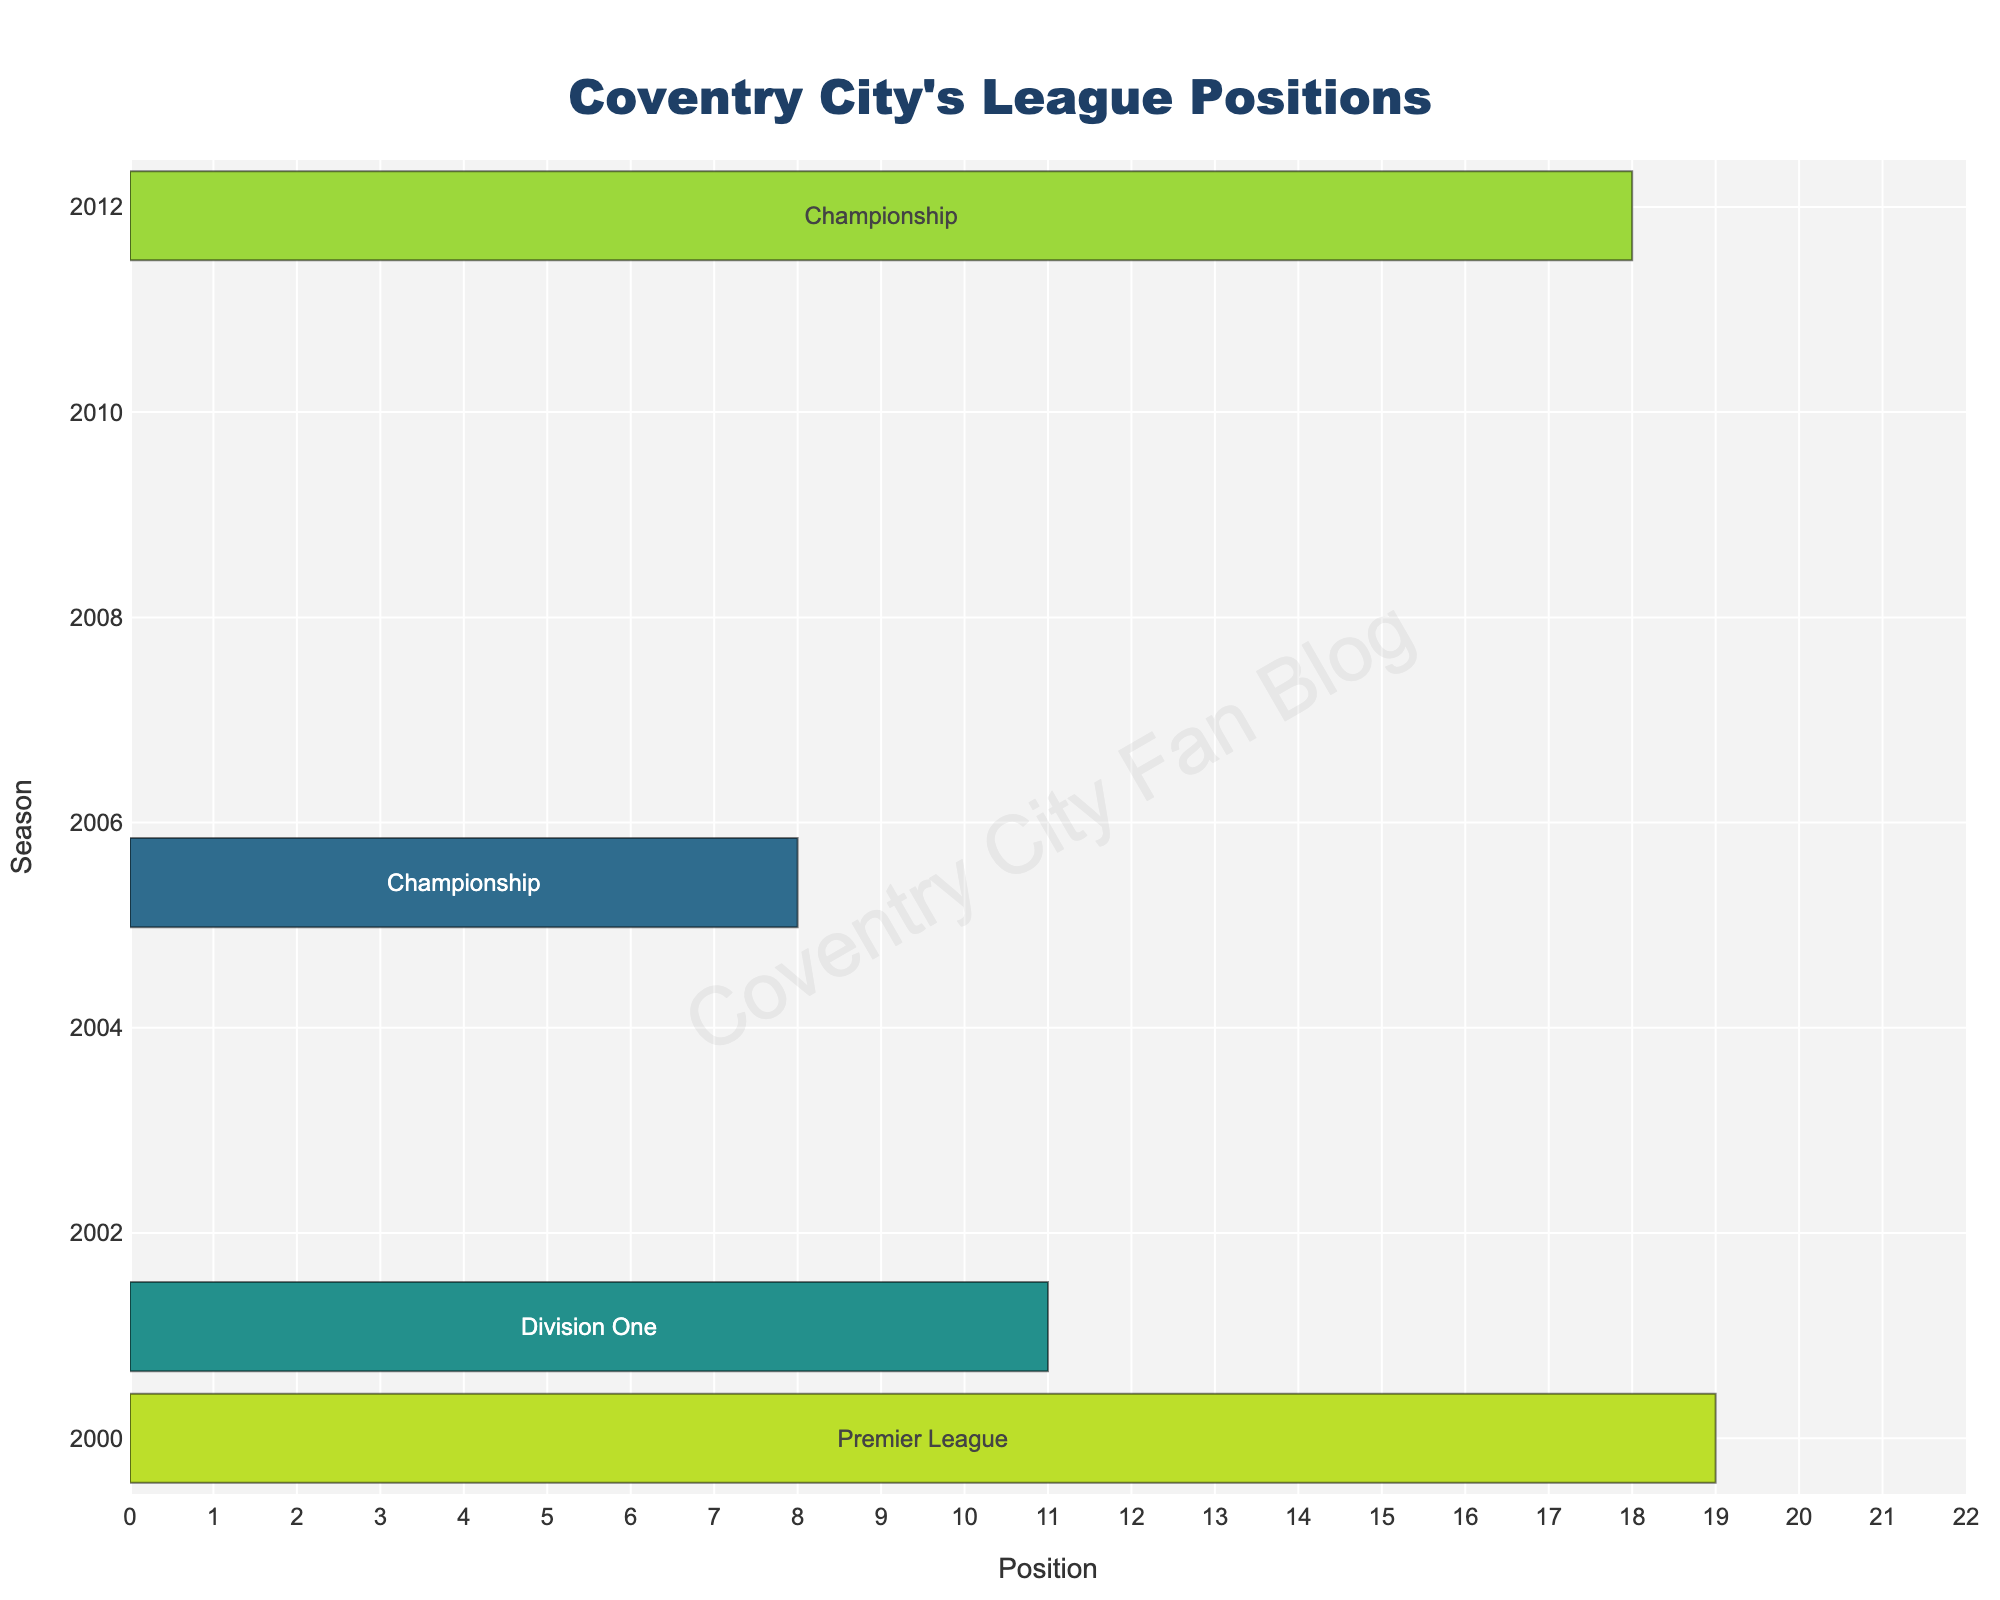What was Coventry City's best league position since joining the Football League? The bar chart indicates that Coventry City's best performance was 1st place in several seasons. Specifically, the seasons 1924-25 in Division Three (North), 1936-37 in Division Two, 1967-68 in Division Two, and 2019-20 in League One all show them finishing in 1st place.
Answer: 1st How many times did Coventry City finish in 1st place in the presented seasons? From the bar chart, we can count four occasions where Coventry City finished in 1st place: during the seasons 1924-25, 1936-37, 1967-68, and 2019-20.
Answer: 4 In which seasons did Coventry City rank in the top 10 of their league? By examining the figure, we can identify several seasons: 1924-25 (1st), 1936-37 (1st), 1967-68 (1st), 1970-71 (6th), 1977-78 (7th), 1986-87 (10th), 2005-06 (8th), 2017-18 (6th), and 2022-23 (5th).
Answer: 1924-25, 1936-37, 1967-68, 1970-71, 1977-78, 1986-87, 2005-06, 2017-18, 2022-23 Which was Coventry City's most recent top-5 finish before 2022-23? By visually tracing the bar chart, Coventry City's most recent top-5 finish before the 2022-23 season was in 1967-68 when they finished 1st in Division Two.
Answer: 1967-68 Compare the 2019-20 and 2020-21 seasons. Did Coventry City's league position improve or worsen? The bar chart reveals that Coventry City finished 1st in League One in the 2019-20 season and then 16th in the Championship in the 2020-21 season. This shows a deterioration in league position from 1st to 16th.
Answer: Worsen What pattern can be observed about Coventry City's league positions from 2017-18 to 2022-23? Observing the figure, Coventry City moved from League Two (6th in 2017-18) to League One (8th in 2018-19 and 1st in 2019-20), then to the Championship (16th in 2020-21, 12th in 2021-22, and 5th in 2022-23). The pattern suggests a general trend of improvement in their league standings over these years.
Answer: Improving trend How did Coventry City's league position change after their relegation from the Premier League in 2000-01? The figure indicates Coventry City finished 19th in the Premier League in 2000-01, resulting in relegation. The next season, they were 11th in Division One (2001-02).
Answer: 11th in Division One What is the difference in league positions between the 1970-71 and 1977-78 seasons? Coventry City finished 6th in Division One in 1970-71 and 7th in Division One in 1977-78. The difference in their positions is 1.
Answer: 1 When comparing the 2005-06 Championship season to the 2011-12 Championship season, which season had a better league position? In the 2005-06 Championship season, Coventry City finished 8th. In the 2011-12 Championship season, they finished 18th. Therefore, 2005-06 had a better league position.
Answer: 2005-06 